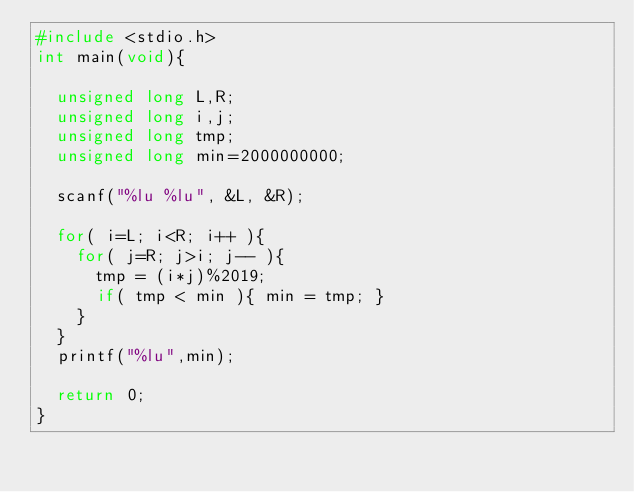Convert code to text. <code><loc_0><loc_0><loc_500><loc_500><_C_>#include <stdio.h>
int main(void){

  unsigned long	L,R;
  unsigned long	i,j;
  unsigned long	tmp;
  unsigned long	min=2000000000;
  
  scanf("%lu %lu", &L, &R);
  
  for( i=L; i<R; i++ ){
    for( j=R; j>i; j-- ){
      tmp = (i*j)%2019;
      if( tmp < min ){ min = tmp; }
    }
  }
  printf("%lu",min);

  return 0;
}</code> 